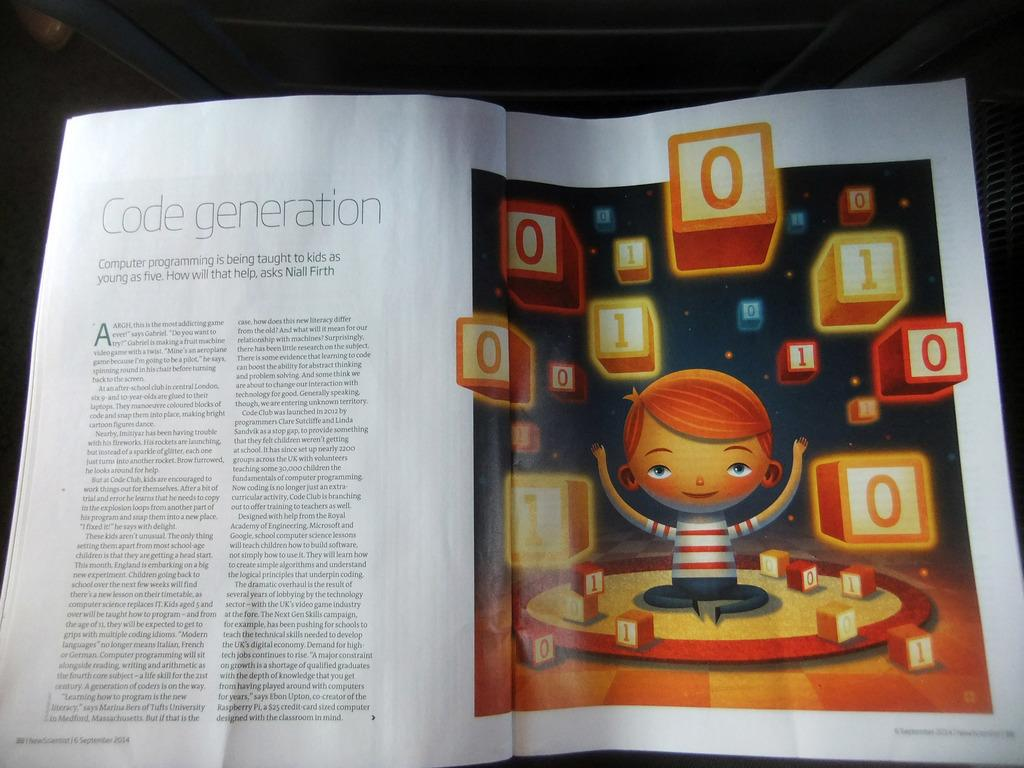<image>
Create a compact narrative representing the image presented. the numbers 0 that are on the book 